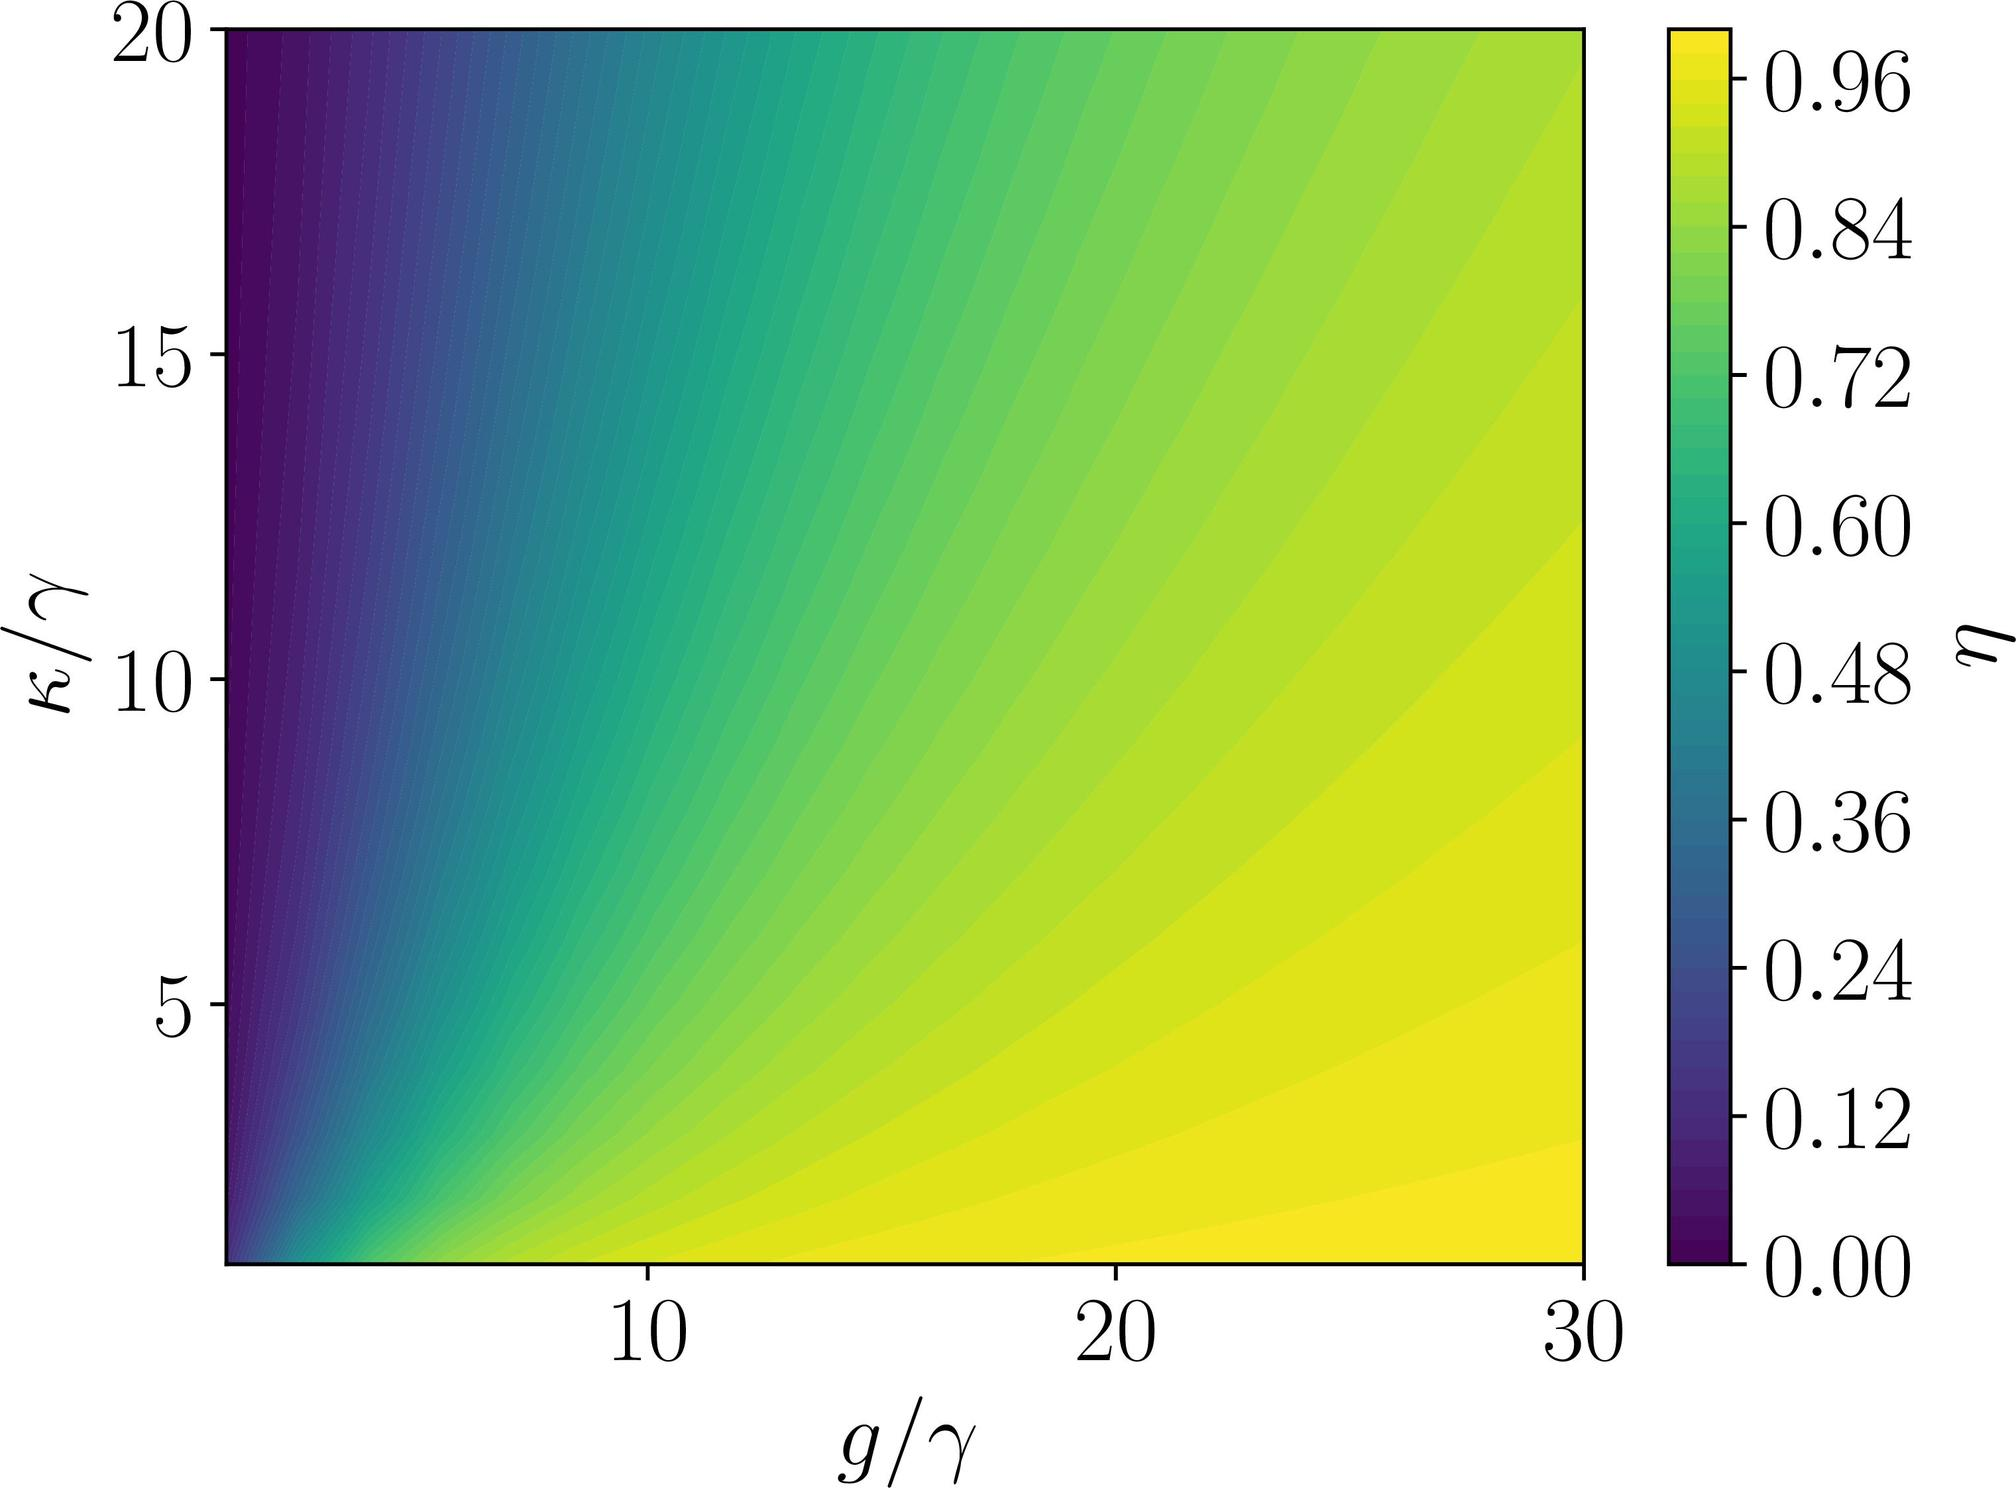If \( g/\gamma \) is increased from 10 to 20 while keeping \( \kappa/\gamma \) constant at 5, how does \( \eta \) change according to the figure? A) \( \eta \) increases B) \( \eta \) decreases C) \( \eta \) remains constant D) There is not enough information to determine Upon examining the given contour plot, we can see that the variable \( \eta \) is represented by the color scale on the right, with darker colors corresponding to lower values. As we trace a horizontal line at \( \kappa/\gamma = 5 \), moving right to increase \( g/\gamma \) from 10 to 20, there is a clear transition from a lighter shade (indicating a higher value of \( \eta \)) to a darker shade. This shift signifies a reducing value of \( \eta \). Hence, as \( g/\gamma \) increases within the specified range and \( \kappa/\gamma \) is held constant, \( \eta \) indeed decreases, making option B the correct answer. 